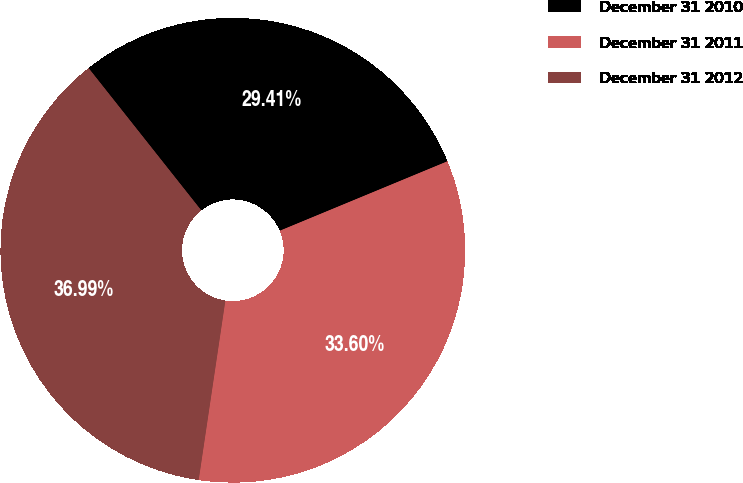Convert chart to OTSL. <chart><loc_0><loc_0><loc_500><loc_500><pie_chart><fcel>December 31 2010<fcel>December 31 2011<fcel>December 31 2012<nl><fcel>29.41%<fcel>33.6%<fcel>36.99%<nl></chart> 